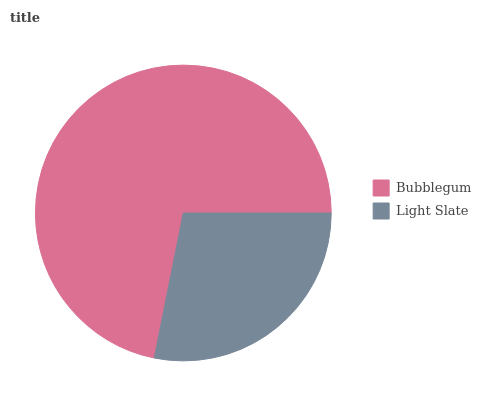Is Light Slate the minimum?
Answer yes or no. Yes. Is Bubblegum the maximum?
Answer yes or no. Yes. Is Light Slate the maximum?
Answer yes or no. No. Is Bubblegum greater than Light Slate?
Answer yes or no. Yes. Is Light Slate less than Bubblegum?
Answer yes or no. Yes. Is Light Slate greater than Bubblegum?
Answer yes or no. No. Is Bubblegum less than Light Slate?
Answer yes or no. No. Is Bubblegum the high median?
Answer yes or no. Yes. Is Light Slate the low median?
Answer yes or no. Yes. Is Light Slate the high median?
Answer yes or no. No. Is Bubblegum the low median?
Answer yes or no. No. 